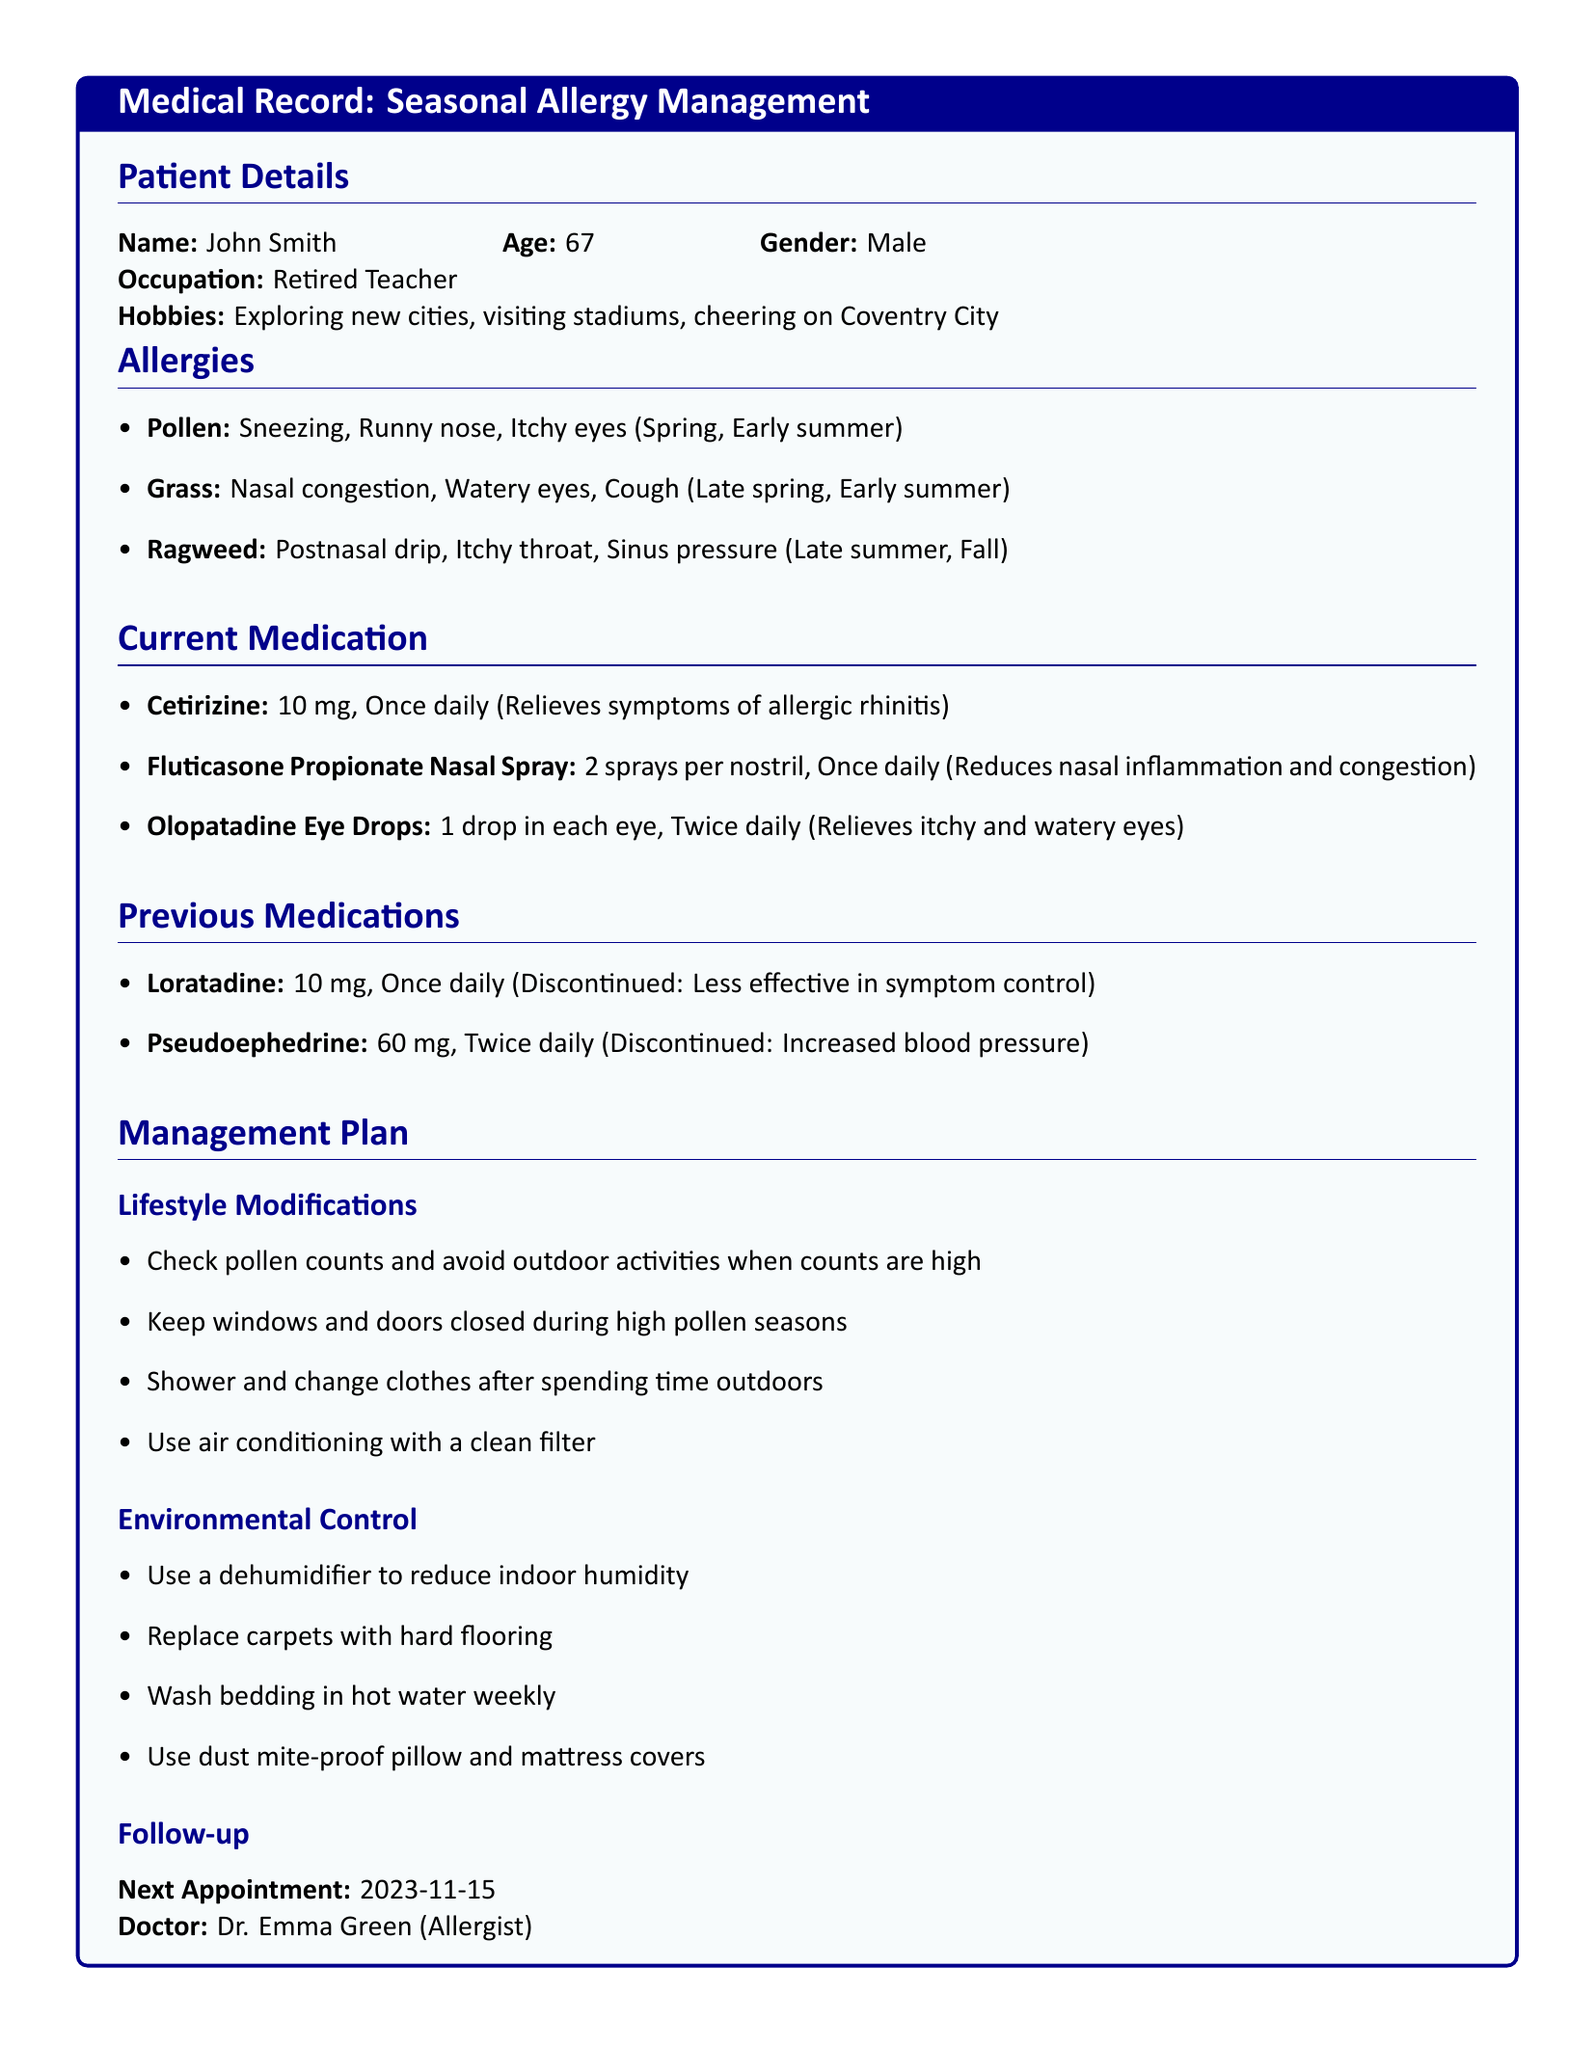What is the patient's name? The patient's name is found in the Patient Details section of the document.
Answer: John Smith What is the age of the patient? The age of the patient is also indicated in the Patient Details section.
Answer: 67 What medication is taken once daily for allergic rhinitis? The medication used for allergic rhinitis is listed under Current Medication.
Answer: Cetirizine What symptoms are associated with Ragweed allergies? The symptoms related to Ragweed can be found under the Allergies section.
Answer: Postnasal drip, Itchy throat, Sinus pressure When is the next appointment scheduled? The date of the next appointment is provided in the Follow-up section.
Answer: 2023-11-15 Why was loratadine discontinued? The reason for discontinuation is mentioned in the Previous Medications section.
Answer: Less effective in symptom control What type of doctor is Dr. Emma Green? Dr. Emma Green's specialization is noted in the Follow-up section.
Answer: Allergist What is one lifestyle modification recommended? Suggested lifestyle modifications can be referenced in the Management Plan section.
Answer: Check pollen counts and avoid outdoor activities when counts are high 